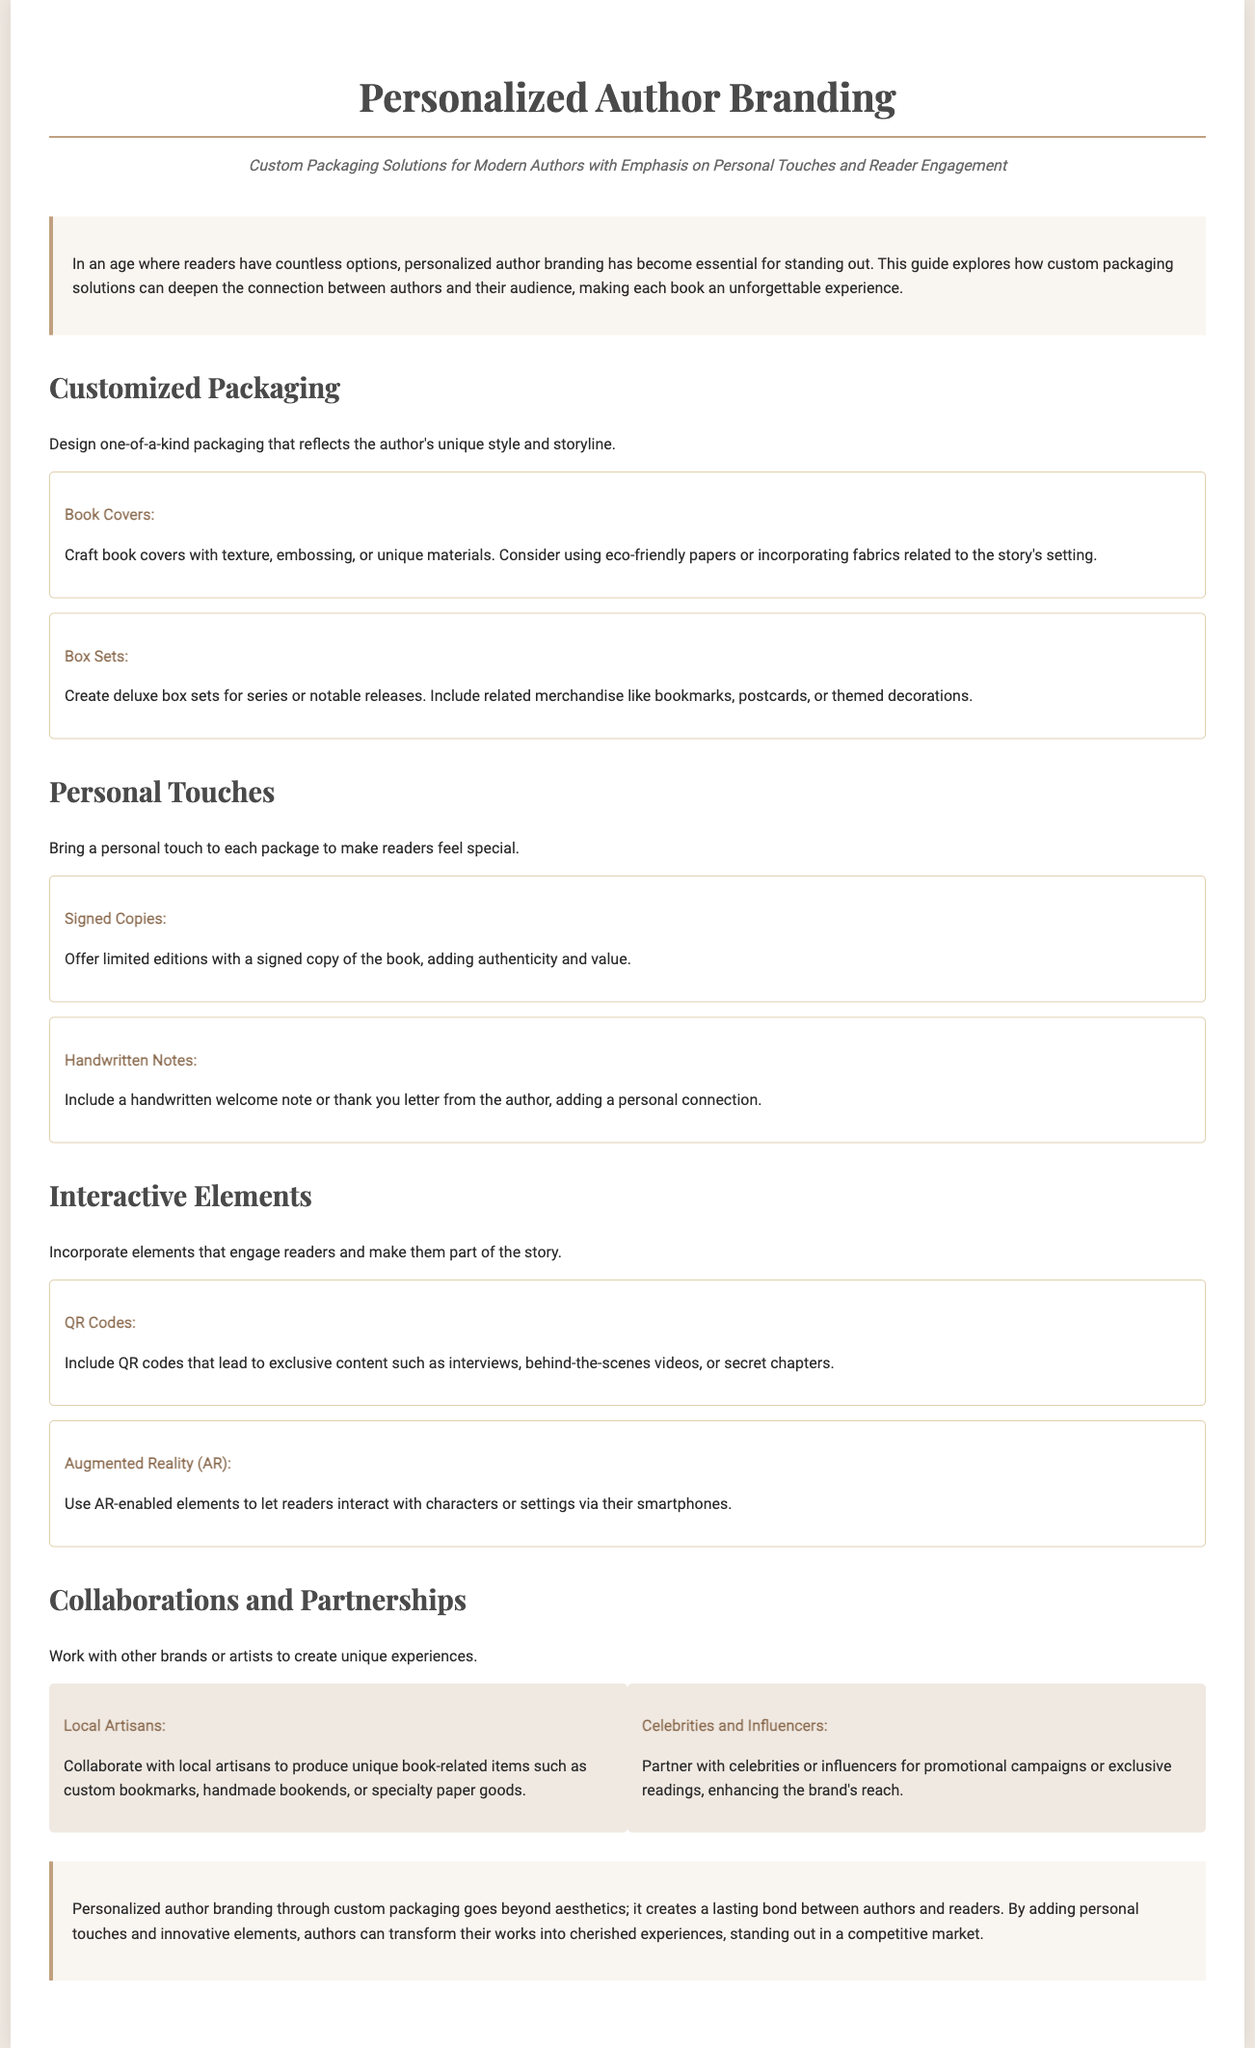what is the title of the document? The title is explicitly mentioned at the beginning of the document under the header section.
Answer: Personalized Author Branding what is a key benefit of personalized author branding? The benefit is outlined in the introductory section which discusses the importance of standing out in a crowded market.
Answer: Standing out what type of elements are suggested for creating engagement? This is noted under the "Interactive Elements" section, highlighting specific features intended for reader interaction.
Answer: QR Codes what is one example of a personal touch mentioned in the document? The examples can be found listed under the "Personal Touches" section where various options are provided.
Answer: Signed Copies how can authors enhance their brand through collaborations? This is elaborated on in the "Collaborations and Partnerships" section touting the potential benefits of partnerships.
Answer: Unique experiences what material can be used for crafting book covers? The document specifies materials for various packaging elements, found under the "Customized Packaging" section.
Answer: Eco-friendly papers what is one of the interactive technologies mentioned? This question relates to the "Interactive Elements" section which presents modern technological approaches for reader engagement.
Answer: Augmented Reality how do local artisans contribute to author branding? This relates to specific collaborative strategies discussed in the "Collaborations and Partnerships" section, explaining the potential contributions.
Answer: Unique book-related items what is a notable feature of deluxe box sets? This information is active in the "Customized Packaging" section, detailing components for enhanced offerings.
Answer: Related merchandise 